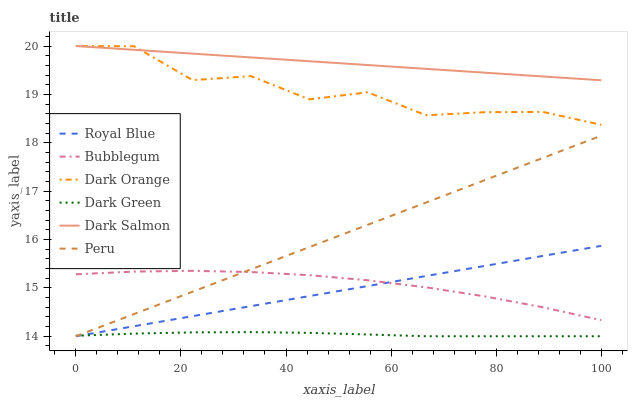Does Dark Green have the minimum area under the curve?
Answer yes or no. Yes. Does Dark Salmon have the maximum area under the curve?
Answer yes or no. Yes. Does Bubblegum have the minimum area under the curve?
Answer yes or no. No. Does Bubblegum have the maximum area under the curve?
Answer yes or no. No. Is Royal Blue the smoothest?
Answer yes or no. Yes. Is Dark Orange the roughest?
Answer yes or no. Yes. Is Dark Salmon the smoothest?
Answer yes or no. No. Is Dark Salmon the roughest?
Answer yes or no. No. Does Royal Blue have the lowest value?
Answer yes or no. Yes. Does Bubblegum have the lowest value?
Answer yes or no. No. Does Dark Salmon have the highest value?
Answer yes or no. Yes. Does Bubblegum have the highest value?
Answer yes or no. No. Is Bubblegum less than Dark Orange?
Answer yes or no. Yes. Is Dark Orange greater than Dark Green?
Answer yes or no. Yes. Does Peru intersect Royal Blue?
Answer yes or no. Yes. Is Peru less than Royal Blue?
Answer yes or no. No. Is Peru greater than Royal Blue?
Answer yes or no. No. Does Bubblegum intersect Dark Orange?
Answer yes or no. No. 